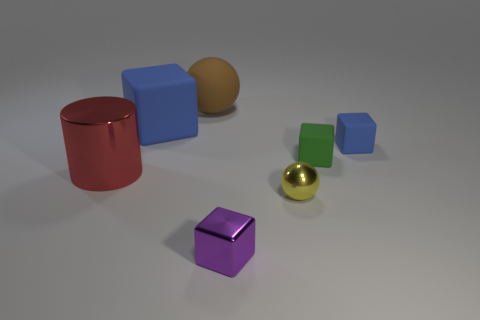Subtract all small metal cubes. How many cubes are left? 3 Subtract 1 cubes. How many cubes are left? 3 Add 2 green rubber blocks. How many objects exist? 9 Subtract all gray blocks. Subtract all yellow balls. How many blocks are left? 4 Subtract all balls. How many objects are left? 5 Subtract all red things. Subtract all green rubber cubes. How many objects are left? 5 Add 6 shiny cylinders. How many shiny cylinders are left? 7 Add 1 spheres. How many spheres exist? 3 Subtract 0 brown cubes. How many objects are left? 7 